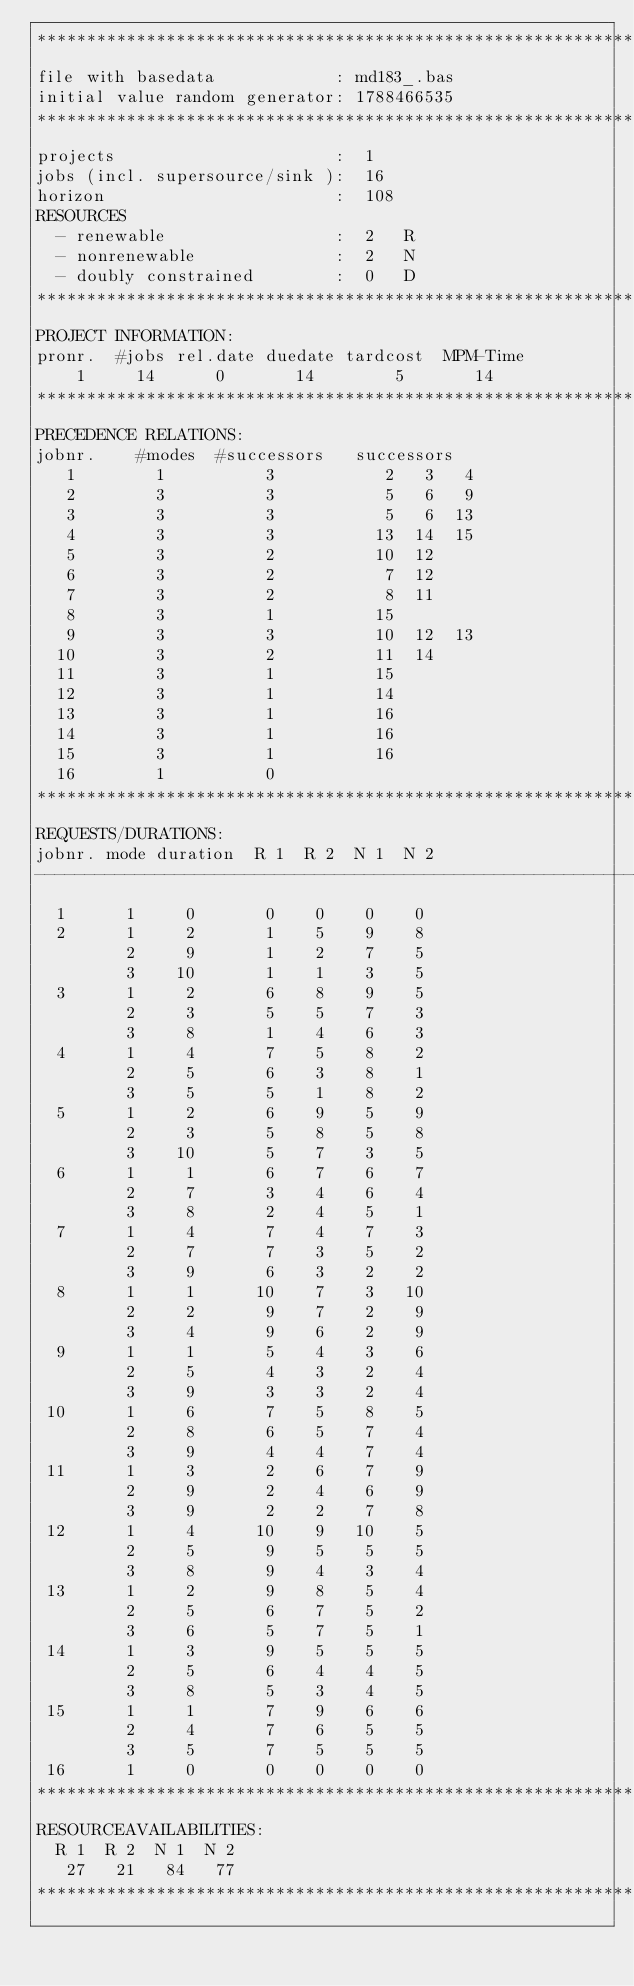<code> <loc_0><loc_0><loc_500><loc_500><_ObjectiveC_>************************************************************************
file with basedata            : md183_.bas
initial value random generator: 1788466535
************************************************************************
projects                      :  1
jobs (incl. supersource/sink ):  16
horizon                       :  108
RESOURCES
  - renewable                 :  2   R
  - nonrenewable              :  2   N
  - doubly constrained        :  0   D
************************************************************************
PROJECT INFORMATION:
pronr.  #jobs rel.date duedate tardcost  MPM-Time
    1     14      0       14        5       14
************************************************************************
PRECEDENCE RELATIONS:
jobnr.    #modes  #successors   successors
   1        1          3           2   3   4
   2        3          3           5   6   9
   3        3          3           5   6  13
   4        3          3          13  14  15
   5        3          2          10  12
   6        3          2           7  12
   7        3          2           8  11
   8        3          1          15
   9        3          3          10  12  13
  10        3          2          11  14
  11        3          1          15
  12        3          1          14
  13        3          1          16
  14        3          1          16
  15        3          1          16
  16        1          0        
************************************************************************
REQUESTS/DURATIONS:
jobnr. mode duration  R 1  R 2  N 1  N 2
------------------------------------------------------------------------
  1      1     0       0    0    0    0
  2      1     2       1    5    9    8
         2     9       1    2    7    5
         3    10       1    1    3    5
  3      1     2       6    8    9    5
         2     3       5    5    7    3
         3     8       1    4    6    3
  4      1     4       7    5    8    2
         2     5       6    3    8    1
         3     5       5    1    8    2
  5      1     2       6    9    5    9
         2     3       5    8    5    8
         3    10       5    7    3    5
  6      1     1       6    7    6    7
         2     7       3    4    6    4
         3     8       2    4    5    1
  7      1     4       7    4    7    3
         2     7       7    3    5    2
         3     9       6    3    2    2
  8      1     1      10    7    3   10
         2     2       9    7    2    9
         3     4       9    6    2    9
  9      1     1       5    4    3    6
         2     5       4    3    2    4
         3     9       3    3    2    4
 10      1     6       7    5    8    5
         2     8       6    5    7    4
         3     9       4    4    7    4
 11      1     3       2    6    7    9
         2     9       2    4    6    9
         3     9       2    2    7    8
 12      1     4      10    9   10    5
         2     5       9    5    5    5
         3     8       9    4    3    4
 13      1     2       9    8    5    4
         2     5       6    7    5    2
         3     6       5    7    5    1
 14      1     3       9    5    5    5
         2     5       6    4    4    5
         3     8       5    3    4    5
 15      1     1       7    9    6    6
         2     4       7    6    5    5
         3     5       7    5    5    5
 16      1     0       0    0    0    0
************************************************************************
RESOURCEAVAILABILITIES:
  R 1  R 2  N 1  N 2
   27   21   84   77
************************************************************************
</code> 